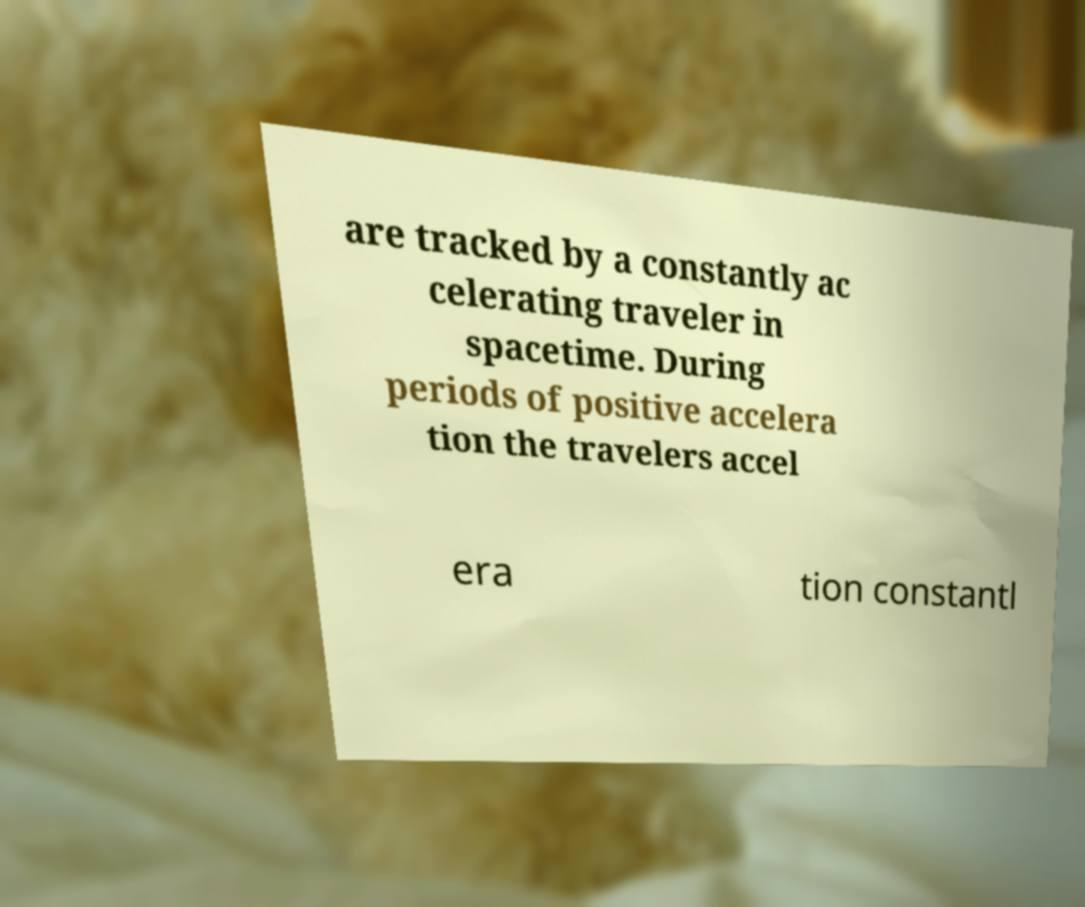For documentation purposes, I need the text within this image transcribed. Could you provide that? are tracked by a constantly ac celerating traveler in spacetime. During periods of positive accelera tion the travelers accel era tion constantl 